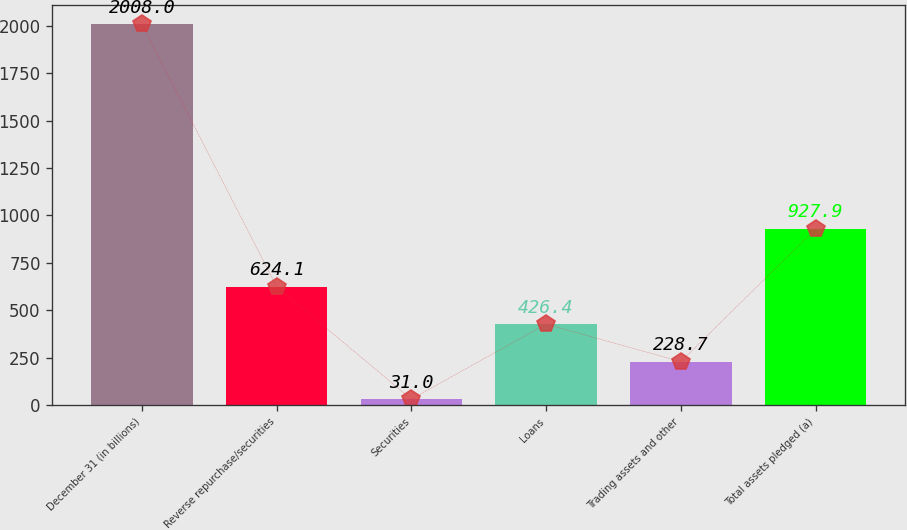Convert chart. <chart><loc_0><loc_0><loc_500><loc_500><bar_chart><fcel>December 31 (in billions)<fcel>Reverse repurchase/securities<fcel>Securities<fcel>Loans<fcel>Trading assets and other<fcel>Total assets pledged (a)<nl><fcel>2008<fcel>624.1<fcel>31<fcel>426.4<fcel>228.7<fcel>927.9<nl></chart> 